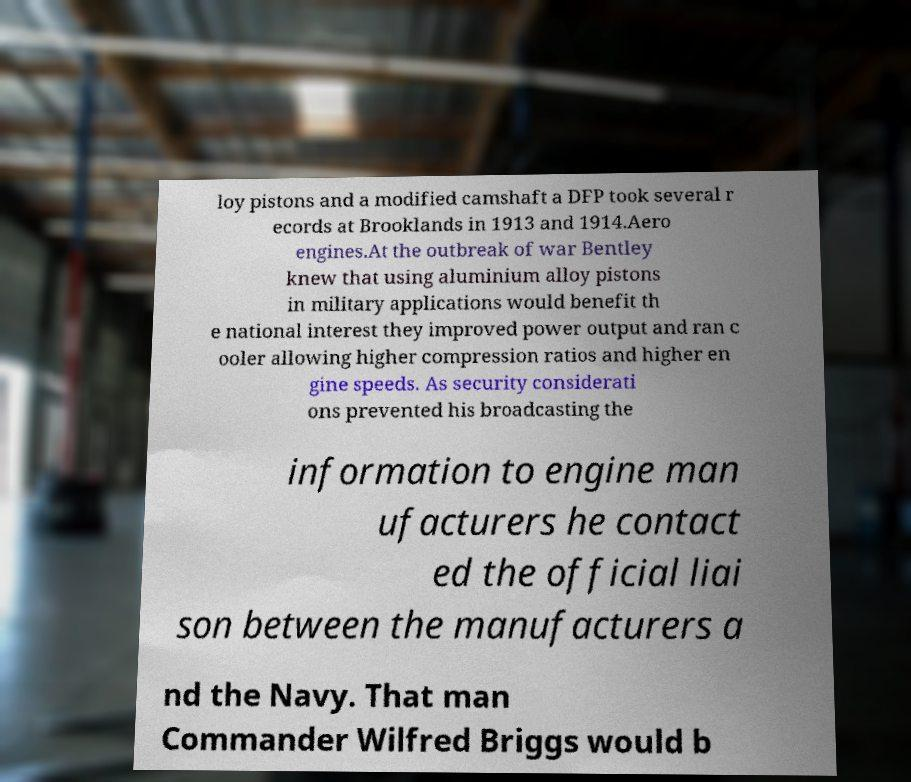Could you assist in decoding the text presented in this image and type it out clearly? loy pistons and a modified camshaft a DFP took several r ecords at Brooklands in 1913 and 1914.Aero engines.At the outbreak of war Bentley knew that using aluminium alloy pistons in military applications would benefit th e national interest they improved power output and ran c ooler allowing higher compression ratios and higher en gine speeds. As security considerati ons prevented his broadcasting the information to engine man ufacturers he contact ed the official liai son between the manufacturers a nd the Navy. That man Commander Wilfred Briggs would b 